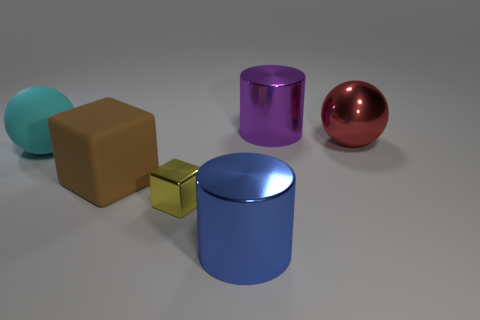What shape is the shiny object that is on the left side of the big blue metallic object?
Your response must be concise. Cube. What size is the metallic object in front of the shiny object that is to the left of the large cylinder that is in front of the metallic ball?
Provide a short and direct response. Large. How many big spheres are on the left side of the shiny cylinder that is in front of the small yellow cube?
Keep it short and to the point. 1. There is a metal object that is both behind the blue object and in front of the large red object; what size is it?
Keep it short and to the point. Small. How many metal objects are small purple balls or big purple things?
Your answer should be compact. 1. What material is the large blue thing?
Give a very brief answer. Metal. There is a sphere that is to the left of the large metal thing that is to the left of the cylinder behind the large cyan matte object; what is it made of?
Provide a succinct answer. Rubber. There is a purple thing that is the same size as the brown object; what shape is it?
Give a very brief answer. Cylinder. How many objects are either large blue cylinders or large shiny cylinders that are in front of the brown matte object?
Your answer should be very brief. 1. Do the ball that is on the left side of the small object and the sphere that is on the right side of the small yellow object have the same material?
Make the answer very short. No. 